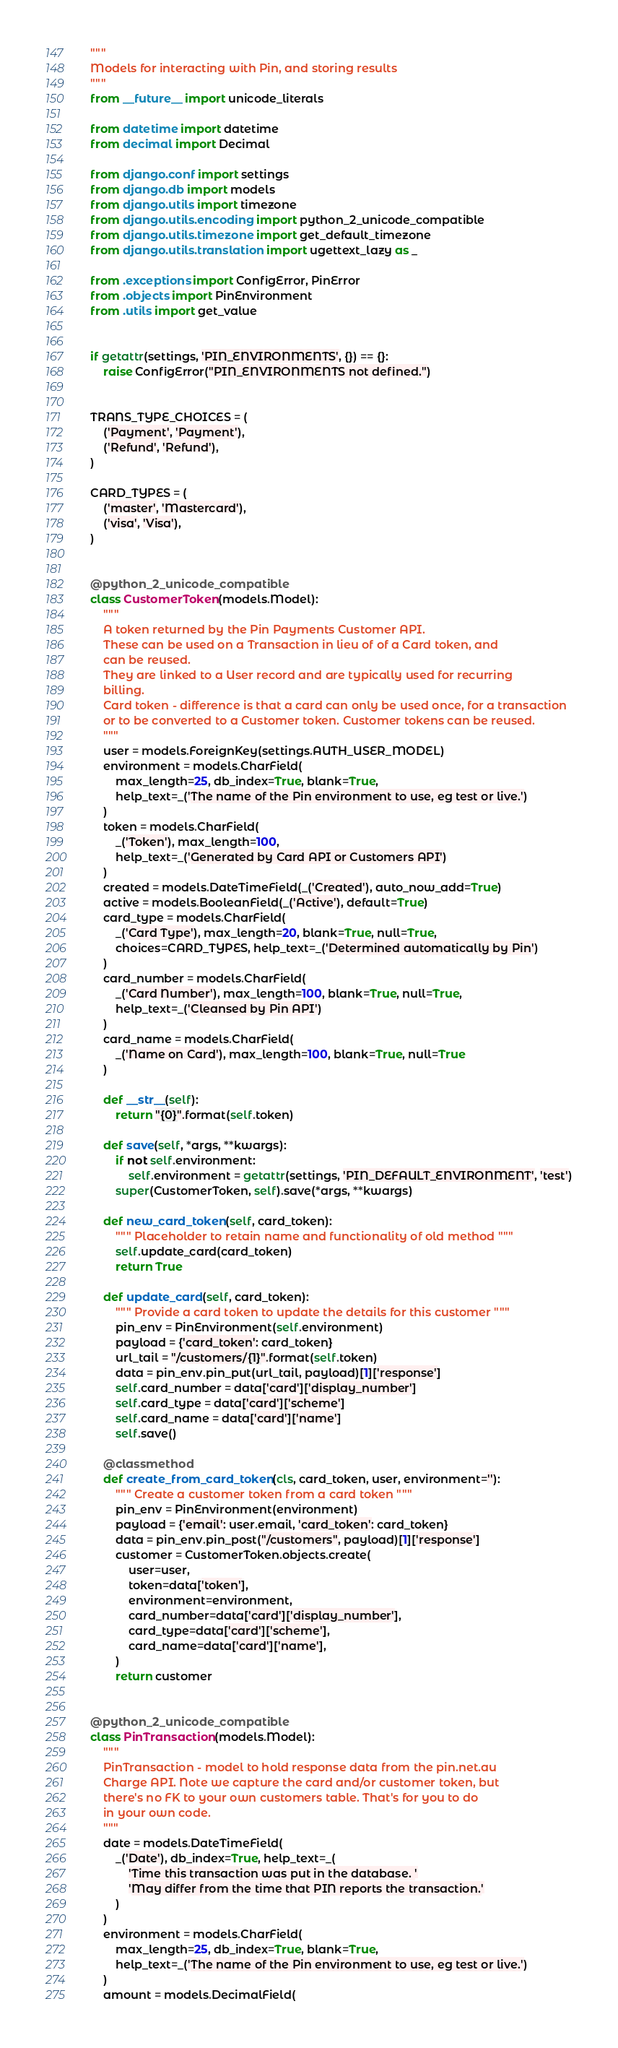<code> <loc_0><loc_0><loc_500><loc_500><_Python_>"""
Models for interacting with Pin, and storing results
"""
from __future__ import unicode_literals

from datetime import datetime
from decimal import Decimal

from django.conf import settings
from django.db import models
from django.utils import timezone
from django.utils.encoding import python_2_unicode_compatible
from django.utils.timezone import get_default_timezone
from django.utils.translation import ugettext_lazy as _

from .exceptions import ConfigError, PinError
from .objects import PinEnvironment
from .utils import get_value


if getattr(settings, 'PIN_ENVIRONMENTS', {}) == {}:
    raise ConfigError("PIN_ENVIRONMENTS not defined.")


TRANS_TYPE_CHOICES = (
    ('Payment', 'Payment'),
    ('Refund', 'Refund'),
)

CARD_TYPES = (
    ('master', 'Mastercard'),
    ('visa', 'Visa'),
)


@python_2_unicode_compatible
class CustomerToken(models.Model):
    """
    A token returned by the Pin Payments Customer API.
    These can be used on a Transaction in lieu of of a Card token, and
    can be reused.
    They are linked to a User record and are typically used for recurring
    billing.
    Card token - difference is that a card can only be used once, for a transaction
    or to be converted to a Customer token. Customer tokens can be reused.
    """
    user = models.ForeignKey(settings.AUTH_USER_MODEL)
    environment = models.CharField(
        max_length=25, db_index=True, blank=True,
        help_text=_('The name of the Pin environment to use, eg test or live.')
    )
    token = models.CharField(
        _('Token'), max_length=100,
        help_text=_('Generated by Card API or Customers API')
    )
    created = models.DateTimeField(_('Created'), auto_now_add=True)
    active = models.BooleanField(_('Active'), default=True)
    card_type = models.CharField(
        _('Card Type'), max_length=20, blank=True, null=True,
        choices=CARD_TYPES, help_text=_('Determined automatically by Pin')
    )
    card_number = models.CharField(
        _('Card Number'), max_length=100, blank=True, null=True,
        help_text=_('Cleansed by Pin API')
    )
    card_name = models.CharField(
        _('Name on Card'), max_length=100, blank=True, null=True
    )

    def __str__(self):
        return "{0}".format(self.token)

    def save(self, *args, **kwargs):
        if not self.environment:
            self.environment = getattr(settings, 'PIN_DEFAULT_ENVIRONMENT', 'test')
        super(CustomerToken, self).save(*args, **kwargs)

    def new_card_token(self, card_token):
        """ Placeholder to retain name and functionality of old method """
        self.update_card(card_token)
        return True

    def update_card(self, card_token):
        """ Provide a card token to update the details for this customer """
        pin_env = PinEnvironment(self.environment)
        payload = {'card_token': card_token}
        url_tail = "/customers/{1}".format(self.token)
        data = pin_env.pin_put(url_tail, payload)[1]['response']
        self.card_number = data['card']['display_number']
        self.card_type = data['card']['scheme']
        self.card_name = data['card']['name']
        self.save()

    @classmethod
    def create_from_card_token(cls, card_token, user, environment=''):
        """ Create a customer token from a card token """
        pin_env = PinEnvironment(environment)
        payload = {'email': user.email, 'card_token': card_token}
        data = pin_env.pin_post("/customers", payload)[1]['response']
        customer = CustomerToken.objects.create(
            user=user,
            token=data['token'],
            environment=environment,
            card_number=data['card']['display_number'],
            card_type=data['card']['scheme'],
            card_name=data['card']['name'],
        )
        return customer


@python_2_unicode_compatible
class PinTransaction(models.Model):
    """
    PinTransaction - model to hold response data from the pin.net.au
    Charge API. Note we capture the card and/or customer token, but
    there's no FK to your own customers table. That's for you to do
    in your own code.
    """
    date = models.DateTimeField(
        _('Date'), db_index=True, help_text=_(
            'Time this transaction was put in the database. '
            'May differ from the time that PIN reports the transaction.'
        )
    )
    environment = models.CharField(
        max_length=25, db_index=True, blank=True,
        help_text=_('The name of the Pin environment to use, eg test or live.')
    )
    amount = models.DecimalField(</code> 